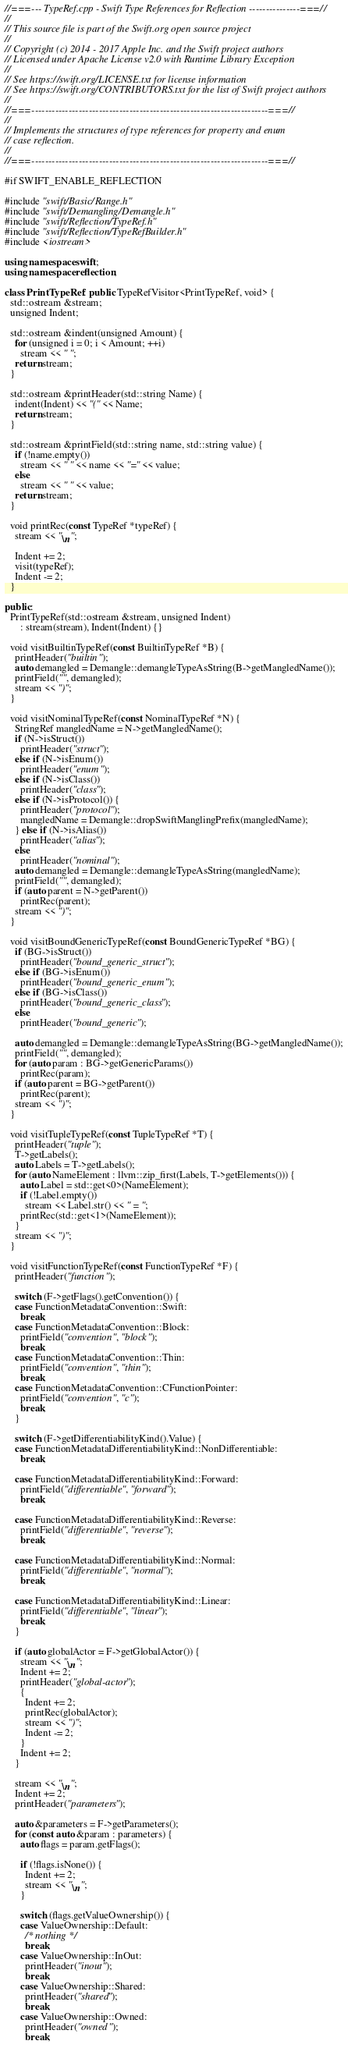<code> <loc_0><loc_0><loc_500><loc_500><_C++_>//===--- TypeRef.cpp - Swift Type References for Reflection ---------------===//
//
// This source file is part of the Swift.org open source project
//
// Copyright (c) 2014 - 2017 Apple Inc. and the Swift project authors
// Licensed under Apache License v2.0 with Runtime Library Exception
//
// See https://swift.org/LICENSE.txt for license information
// See https://swift.org/CONTRIBUTORS.txt for the list of Swift project authors
//
//===----------------------------------------------------------------------===//
//
// Implements the structures of type references for property and enum
// case reflection.
//
//===----------------------------------------------------------------------===//

#if SWIFT_ENABLE_REFLECTION

#include "swift/Basic/Range.h"
#include "swift/Demangling/Demangle.h"
#include "swift/Reflection/TypeRef.h"
#include "swift/Reflection/TypeRefBuilder.h"
#include <iostream>

using namespace swift;
using namespace reflection;

class PrintTypeRef : public TypeRefVisitor<PrintTypeRef, void> {
  std::ostream &stream;
  unsigned Indent;

  std::ostream &indent(unsigned Amount) {
    for (unsigned i = 0; i < Amount; ++i)
      stream << " ";
    return stream;
  }

  std::ostream &printHeader(std::string Name) {
    indent(Indent) << "(" << Name;
    return stream;
  }

  std::ostream &printField(std::string name, std::string value) {
    if (!name.empty())
      stream << " " << name << "=" << value;
    else
      stream << " " << value;
    return stream;
  }

  void printRec(const TypeRef *typeRef) {
    stream << "\n";

    Indent += 2;
    visit(typeRef);
    Indent -= 2;
  }

public:
  PrintTypeRef(std::ostream &stream, unsigned Indent)
      : stream(stream), Indent(Indent) {}

  void visitBuiltinTypeRef(const BuiltinTypeRef *B) {
    printHeader("builtin");
    auto demangled = Demangle::demangleTypeAsString(B->getMangledName());
    printField("", demangled);
    stream << ")";
  }

  void visitNominalTypeRef(const NominalTypeRef *N) {
    StringRef mangledName = N->getMangledName();
    if (N->isStruct())
      printHeader("struct");
    else if (N->isEnum())
      printHeader("enum");
    else if (N->isClass())
      printHeader("class");
    else if (N->isProtocol()) {
      printHeader("protocol");
      mangledName = Demangle::dropSwiftManglingPrefix(mangledName);
    } else if (N->isAlias())
      printHeader("alias");
    else
      printHeader("nominal");
    auto demangled = Demangle::demangleTypeAsString(mangledName);
    printField("", demangled);
    if (auto parent = N->getParent())
      printRec(parent);
    stream << ")";
  }

  void visitBoundGenericTypeRef(const BoundGenericTypeRef *BG) {
    if (BG->isStruct())
      printHeader("bound_generic_struct");
    else if (BG->isEnum())
      printHeader("bound_generic_enum");
    else if (BG->isClass())
      printHeader("bound_generic_class");
    else
      printHeader("bound_generic");

    auto demangled = Demangle::demangleTypeAsString(BG->getMangledName());
    printField("", demangled);
    for (auto param : BG->getGenericParams())
      printRec(param);
    if (auto parent = BG->getParent())
      printRec(parent);
    stream << ")";
  }

  void visitTupleTypeRef(const TupleTypeRef *T) {
    printHeader("tuple");
    T->getLabels();
    auto Labels = T->getLabels();
    for (auto NameElement : llvm::zip_first(Labels, T->getElements())) {
      auto Label = std::get<0>(NameElement);
      if (!Label.empty())
        stream << Label.str() << " = ";
      printRec(std::get<1>(NameElement));
    }
    stream << ")";
  }

  void visitFunctionTypeRef(const FunctionTypeRef *F) {
    printHeader("function");

    switch (F->getFlags().getConvention()) {
    case FunctionMetadataConvention::Swift:
      break;
    case FunctionMetadataConvention::Block:
      printField("convention", "block");
      break;
    case FunctionMetadataConvention::Thin:
      printField("convention", "thin");
      break;
    case FunctionMetadataConvention::CFunctionPointer:
      printField("convention", "c");
      break;
    }

    switch (F->getDifferentiabilityKind().Value) {
    case FunctionMetadataDifferentiabilityKind::NonDifferentiable:
      break;

    case FunctionMetadataDifferentiabilityKind::Forward:
      printField("differentiable", "forward");
      break;

    case FunctionMetadataDifferentiabilityKind::Reverse:
      printField("differentiable", "reverse");
      break;

    case FunctionMetadataDifferentiabilityKind::Normal:
      printField("differentiable", "normal");
      break;

    case FunctionMetadataDifferentiabilityKind::Linear:
      printField("differentiable", "linear");
      break;
    }

    if (auto globalActor = F->getGlobalActor()) {
      stream << "\n";
      Indent += 2;
      printHeader("global-actor");
      {
        Indent += 2;
        printRec(globalActor);
        stream << ")";
        Indent -= 2;
      }
      Indent += 2;
    }

    stream << "\n";
    Indent += 2;
    printHeader("parameters");

    auto &parameters = F->getParameters();
    for (const auto &param : parameters) {
      auto flags = param.getFlags();

      if (!flags.isNone()) {
        Indent += 2;
        stream << "\n";
      }

      switch (flags.getValueOwnership()) {
      case ValueOwnership::Default:
        /* nothing */
        break;
      case ValueOwnership::InOut:
        printHeader("inout");
        break;
      case ValueOwnership::Shared:
        printHeader("shared");
        break;
      case ValueOwnership::Owned:
        printHeader("owned");
        break;</code> 